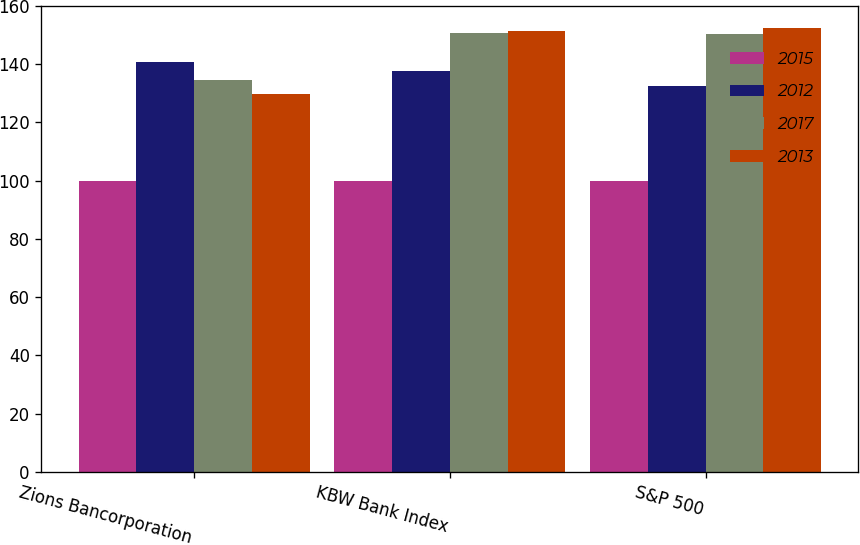<chart> <loc_0><loc_0><loc_500><loc_500><stacked_bar_chart><ecel><fcel>Zions Bancorporation<fcel>KBW Bank Index<fcel>S&P 500<nl><fcel>2015<fcel>100<fcel>100<fcel>100<nl><fcel>2012<fcel>140.6<fcel>137.8<fcel>132.4<nl><fcel>2017<fcel>134.6<fcel>150.7<fcel>150.5<nl><fcel>2013<fcel>129.8<fcel>151.4<fcel>152.5<nl></chart> 